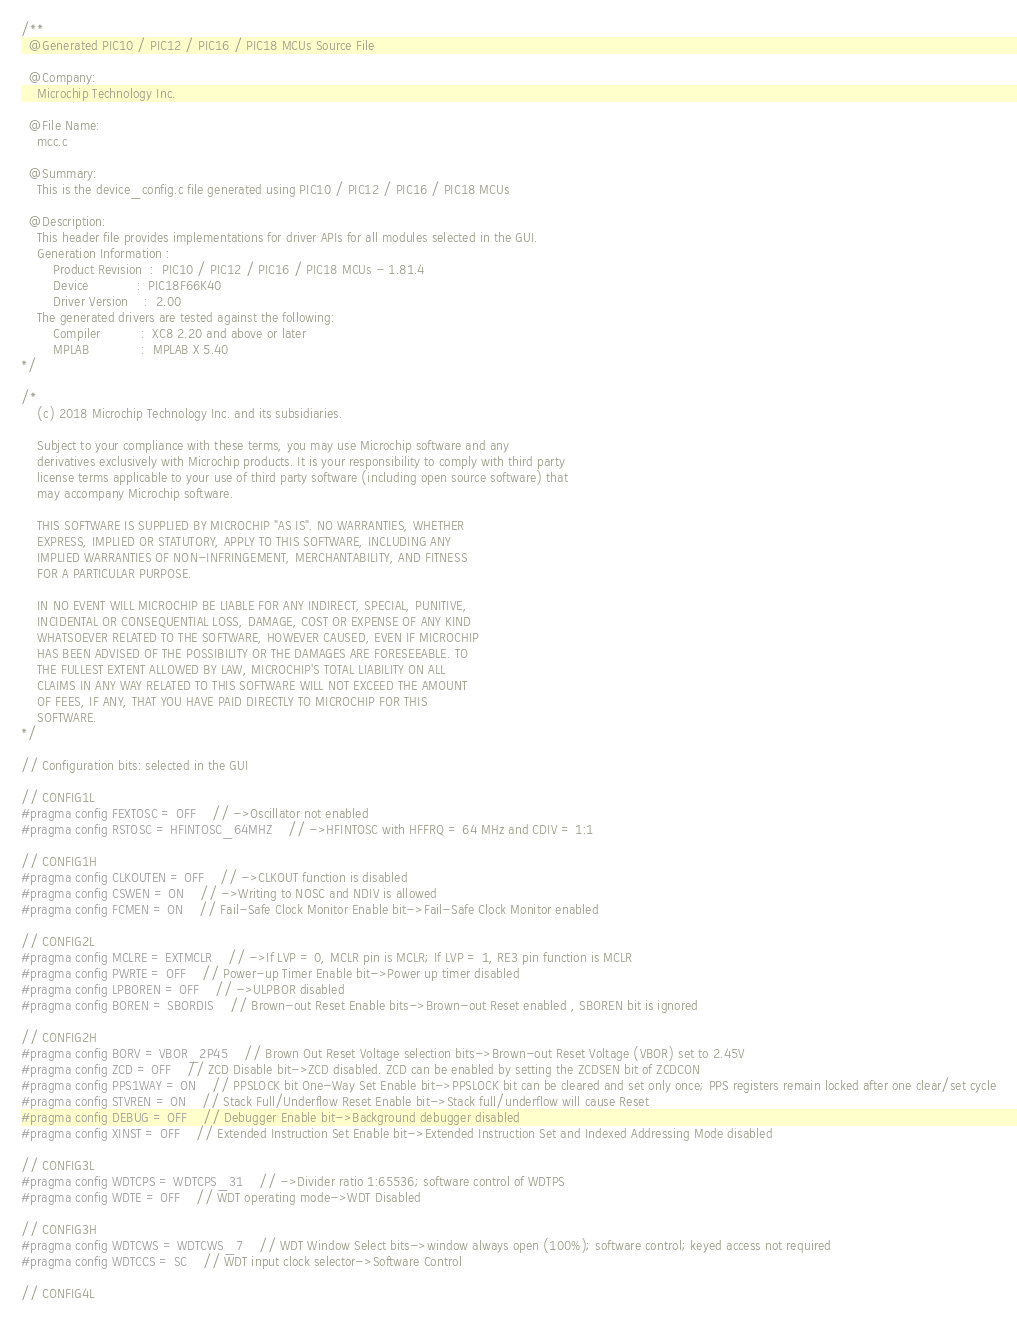<code> <loc_0><loc_0><loc_500><loc_500><_C_>/**
  @Generated PIC10 / PIC12 / PIC16 / PIC18 MCUs Source File

  @Company:
    Microchip Technology Inc.

  @File Name:
    mcc.c

  @Summary:
    This is the device_config.c file generated using PIC10 / PIC12 / PIC16 / PIC18 MCUs

  @Description:
    This header file provides implementations for driver APIs for all modules selected in the GUI.
    Generation Information :
        Product Revision  :  PIC10 / PIC12 / PIC16 / PIC18 MCUs - 1.81.4
        Device            :  PIC18F66K40
        Driver Version    :  2.00
    The generated drivers are tested against the following:
        Compiler          :  XC8 2.20 and above or later
        MPLAB             :  MPLAB X 5.40
*/

/*
    (c) 2018 Microchip Technology Inc. and its subsidiaries. 
    
    Subject to your compliance with these terms, you may use Microchip software and any 
    derivatives exclusively with Microchip products. It is your responsibility to comply with third party 
    license terms applicable to your use of third party software (including open source software) that 
    may accompany Microchip software.
    
    THIS SOFTWARE IS SUPPLIED BY MICROCHIP "AS IS". NO WARRANTIES, WHETHER 
    EXPRESS, IMPLIED OR STATUTORY, APPLY TO THIS SOFTWARE, INCLUDING ANY 
    IMPLIED WARRANTIES OF NON-INFRINGEMENT, MERCHANTABILITY, AND FITNESS 
    FOR A PARTICULAR PURPOSE.
    
    IN NO EVENT WILL MICROCHIP BE LIABLE FOR ANY INDIRECT, SPECIAL, PUNITIVE, 
    INCIDENTAL OR CONSEQUENTIAL LOSS, DAMAGE, COST OR EXPENSE OF ANY KIND 
    WHATSOEVER RELATED TO THE SOFTWARE, HOWEVER CAUSED, EVEN IF MICROCHIP 
    HAS BEEN ADVISED OF THE POSSIBILITY OR THE DAMAGES ARE FORESEEABLE. TO 
    THE FULLEST EXTENT ALLOWED BY LAW, MICROCHIP'S TOTAL LIABILITY ON ALL 
    CLAIMS IN ANY WAY RELATED TO THIS SOFTWARE WILL NOT EXCEED THE AMOUNT 
    OF FEES, IF ANY, THAT YOU HAVE PAID DIRECTLY TO MICROCHIP FOR THIS 
    SOFTWARE.
*/

// Configuration bits: selected in the GUI

// CONFIG1L
#pragma config FEXTOSC = OFF    // ->Oscillator not enabled
#pragma config RSTOSC = HFINTOSC_64MHZ    // ->HFINTOSC with HFFRQ = 64 MHz and CDIV = 1:1

// CONFIG1H
#pragma config CLKOUTEN = OFF    // ->CLKOUT function is disabled
#pragma config CSWEN = ON    // ->Writing to NOSC and NDIV is allowed
#pragma config FCMEN = ON    // Fail-Safe Clock Monitor Enable bit->Fail-Safe Clock Monitor enabled

// CONFIG2L
#pragma config MCLRE = EXTMCLR    // ->If LVP = 0, MCLR pin is MCLR; If LVP = 1, RE3 pin function is MCLR 
#pragma config PWRTE = OFF    // Power-up Timer Enable bit->Power up timer disabled
#pragma config LPBOREN = OFF    // ->ULPBOR disabled
#pragma config BOREN = SBORDIS    // Brown-out Reset Enable bits->Brown-out Reset enabled , SBOREN bit is ignored

// CONFIG2H
#pragma config BORV = VBOR_2P45    // Brown Out Reset Voltage selection bits->Brown-out Reset Voltage (VBOR) set to 2.45V
#pragma config ZCD = OFF    // ZCD Disable bit->ZCD disabled. ZCD can be enabled by setting the ZCDSEN bit of ZCDCON
#pragma config PPS1WAY = ON    // PPSLOCK bit One-Way Set Enable bit->PPSLOCK bit can be cleared and set only once; PPS registers remain locked after one clear/set cycle
#pragma config STVREN = ON    // Stack Full/Underflow Reset Enable bit->Stack full/underflow will cause Reset
#pragma config DEBUG = OFF    // Debugger Enable bit->Background debugger disabled
#pragma config XINST = OFF    // Extended Instruction Set Enable bit->Extended Instruction Set and Indexed Addressing Mode disabled

// CONFIG3L
#pragma config WDTCPS = WDTCPS_31    // ->Divider ratio 1:65536; software control of WDTPS
#pragma config WDTE = OFF    // WDT operating mode->WDT Disabled

// CONFIG3H
#pragma config WDTCWS = WDTCWS_7    // WDT Window Select bits->window always open (100%); software control; keyed access not required
#pragma config WDTCCS = SC    // WDT input clock selector->Software Control

// CONFIG4L</code> 